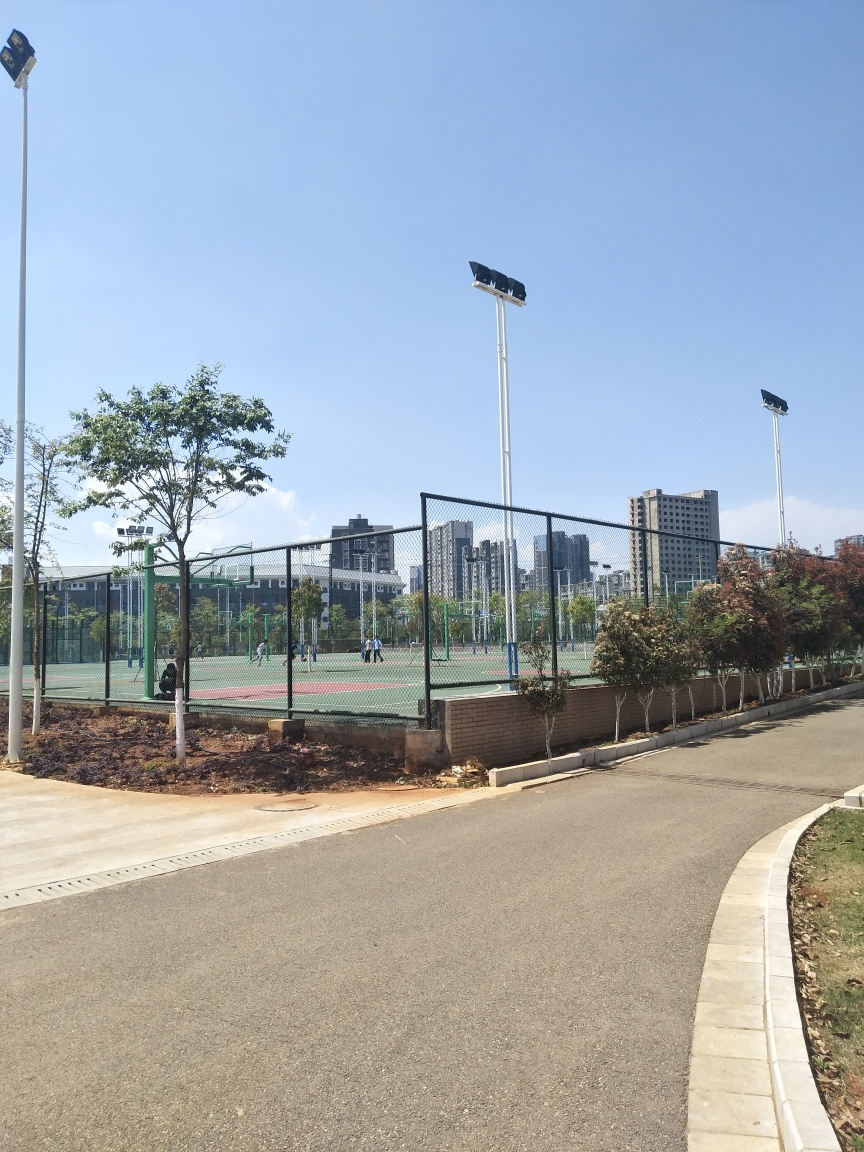What kind of activities seem to be supported by the facilities in the image? The fenced-in areas suggest courts for sports like tennis or basketball, and the wide pathway could be used for walking, jogging, or cycling. 